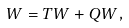<formula> <loc_0><loc_0><loc_500><loc_500>W = T W + Q W ,</formula> 